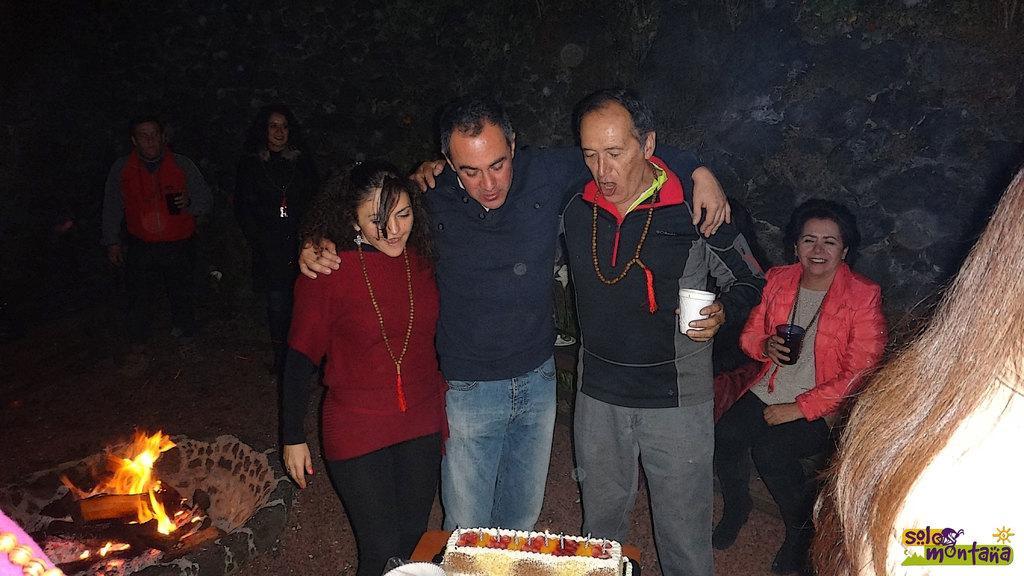Describe this image in one or two sentences. In this image we can see people, glasses, fire and we can also see the trees. 